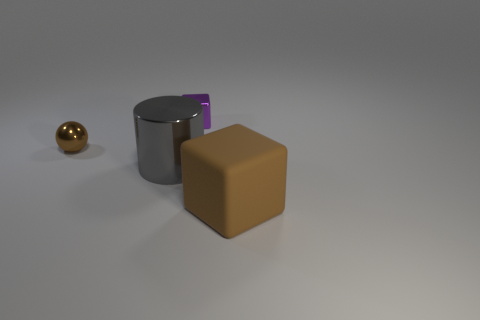Add 2 brown matte blocks. How many objects exist? 6 Subtract all balls. How many objects are left? 3 Subtract all small red metal cylinders. Subtract all small brown metal objects. How many objects are left? 3 Add 3 big shiny objects. How many big shiny objects are left? 4 Add 3 tiny blue cylinders. How many tiny blue cylinders exist? 3 Subtract 0 yellow blocks. How many objects are left? 4 